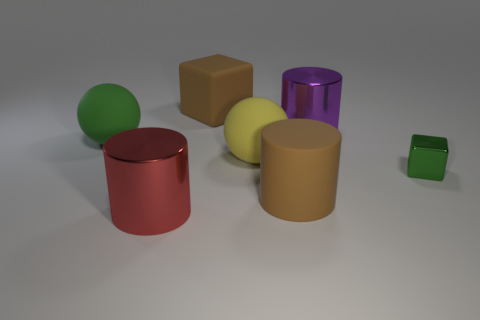Add 2 big green rubber balls. How many objects exist? 9 Subtract all cubes. How many objects are left? 5 Add 4 matte cylinders. How many matte cylinders exist? 5 Subtract 1 green blocks. How many objects are left? 6 Subtract all small blue spheres. Subtract all large objects. How many objects are left? 1 Add 6 big brown things. How many big brown things are left? 8 